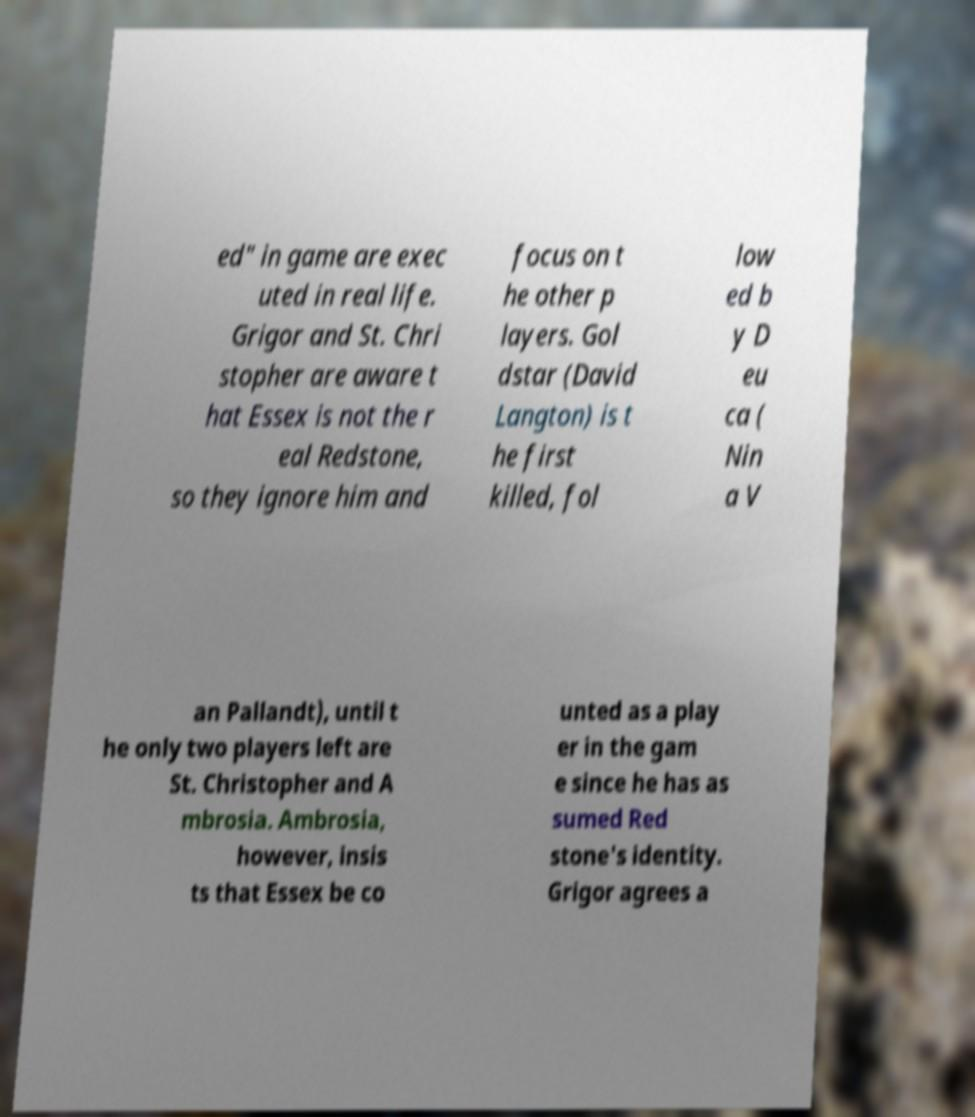There's text embedded in this image that I need extracted. Can you transcribe it verbatim? ed" in game are exec uted in real life. Grigor and St. Chri stopher are aware t hat Essex is not the r eal Redstone, so they ignore him and focus on t he other p layers. Gol dstar (David Langton) is t he first killed, fol low ed b y D eu ca ( Nin a V an Pallandt), until t he only two players left are St. Christopher and A mbrosia. Ambrosia, however, insis ts that Essex be co unted as a play er in the gam e since he has as sumed Red stone's identity. Grigor agrees a 